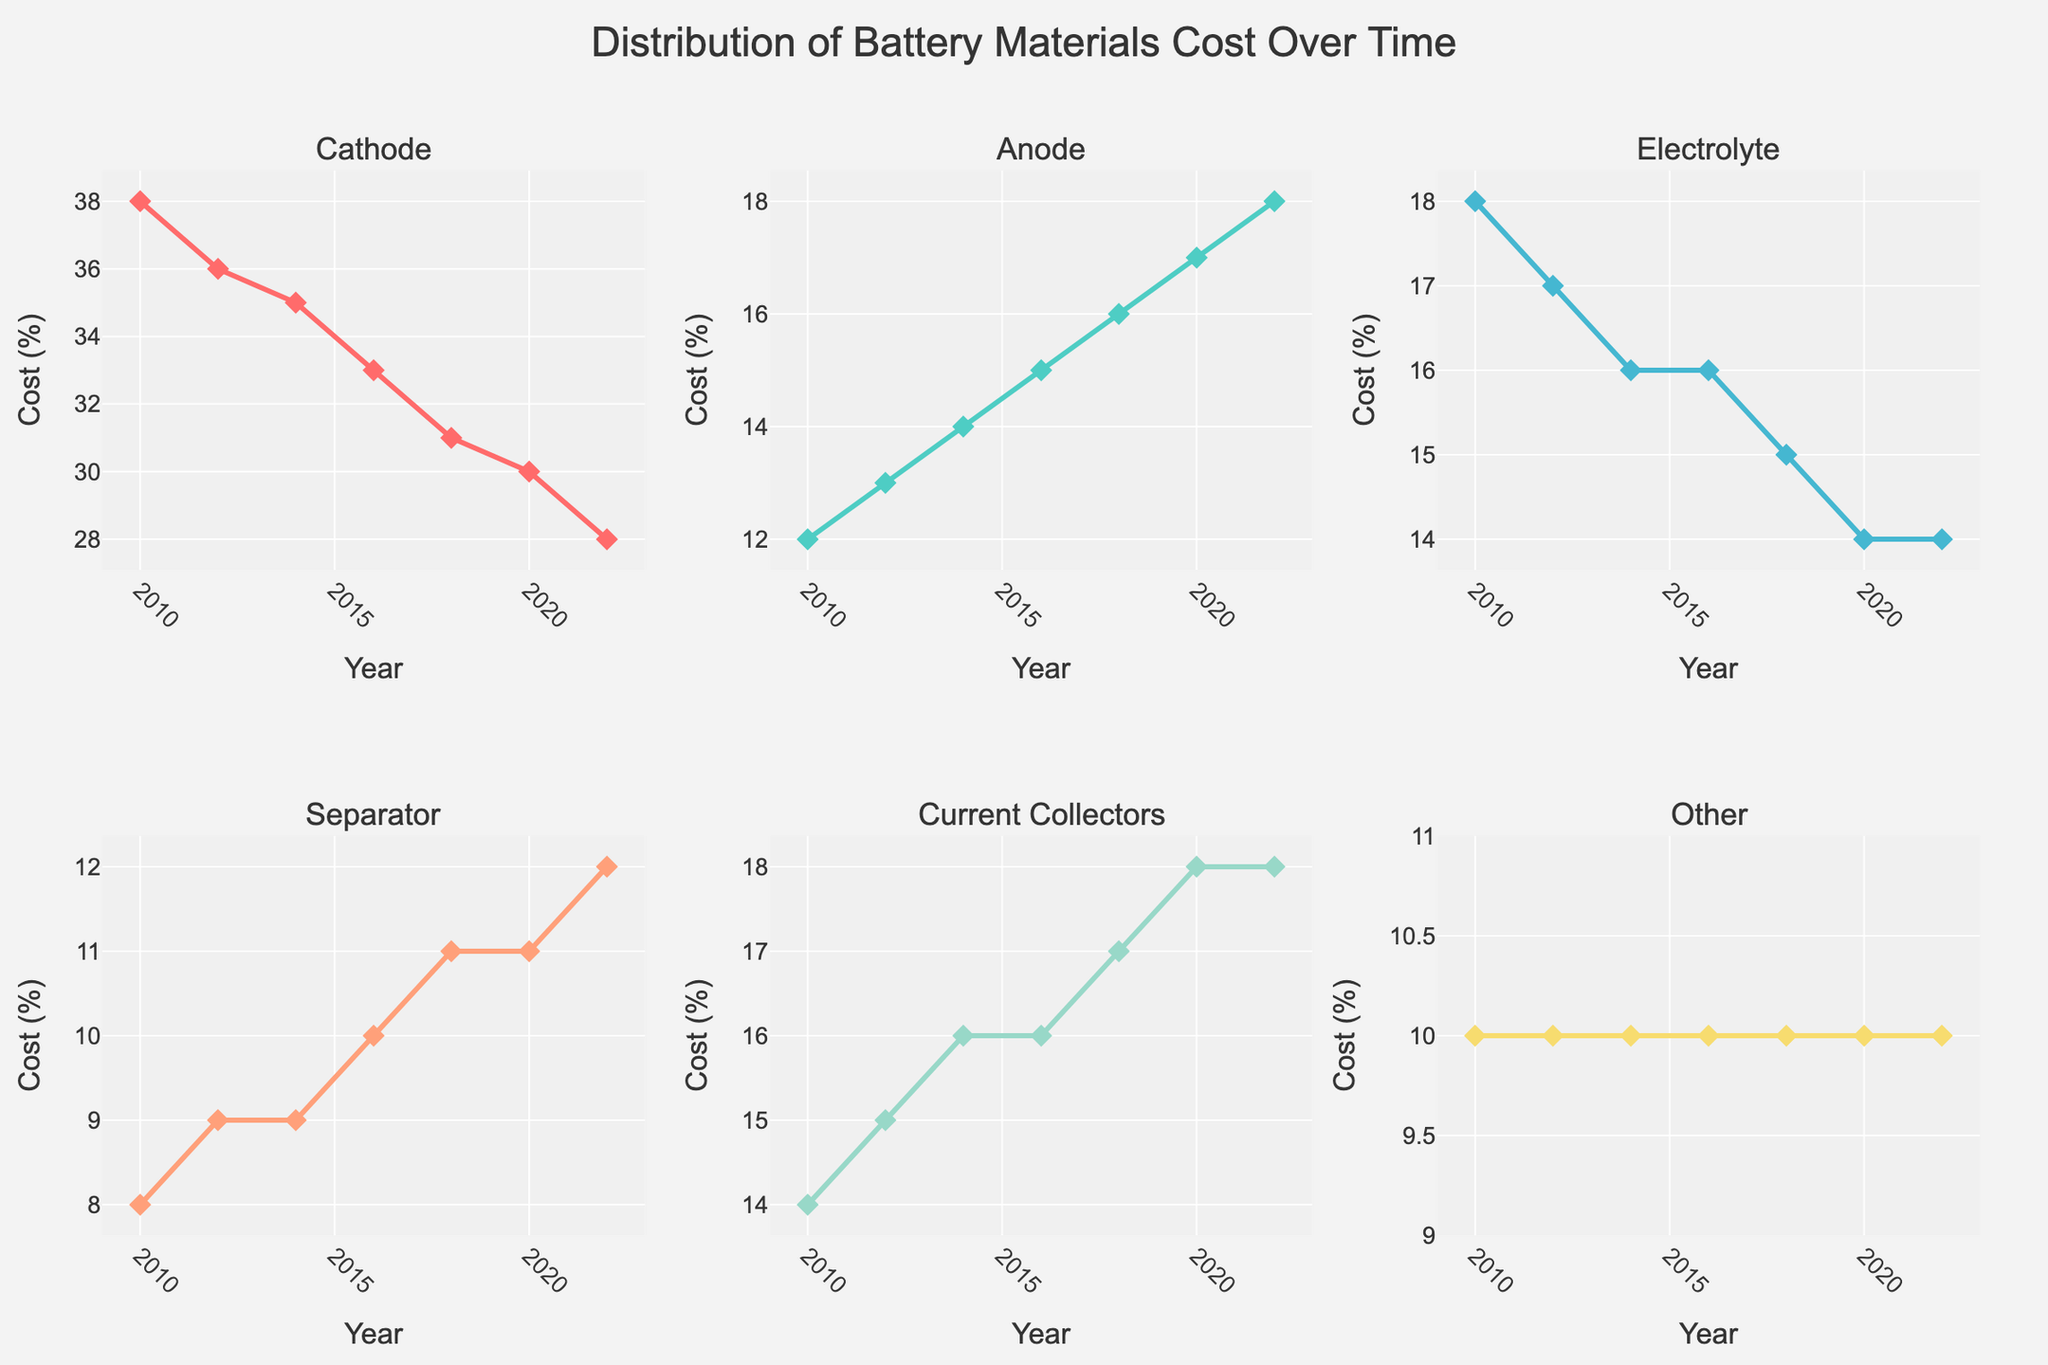What is the title of the figure? The title is usually displayed at the top of the figure. In this case, the title is "Distribution of Battery Materials Cost Over Time."
Answer: Distribution of Battery Materials Cost Over Time Which component had the highest cost percentage in 2022? Look at the subplot for each component and find the one with the highest value in 2022. The Cathode cost percentage is 28% while others are lower.
Answer: Cathode What is the trend for the cost percentage of the Electrolyte from 2010 to 2022? To determine the trend, observe the line in the Electrolyte subplot. The percentage drops from 18% to 14% from 2010 to 2016 and remains constant till 2022.
Answer: Decreasing then Stable By how much did the cost percentage of the Anode increase from 2010 to 2022? Subtract the Anode cost percentage in 2010 from that in 2022. The values are 12% in 2010 and 18% in 2022, a difference of 6%.
Answer: 6% Which component had the most fluctuation in cost percentage over the years? Compare the variability in trends across all subplots. Cathode has a noticeable declining trend, while Separator and Current Collectors show more consistent upward trends. Focus on those with wider fluctuations.
Answer: Cathode What is the average cost percentage of the Separator from 2010 to 2022? Add the Separator cost percentages from each year: 8 + 9 + 9 + 10 + 11 + 11 + 12 = 70. Divide by the number of years (7).
Answer: 10 What year did the Current Collectors cost percentage surpass the separator's cost percentage for the first time? Compare the values for Current Collectors and Separators across the years to see where Current Collectors first exceeds Separator's percentage. In 2016, both are equal at 10%, but in 2018, Current Collectors are 17% and Separator is 11%.
Answer: 2018 Rank the components by their cost percentage in 2010 from highest to lowest. Look at the data for 2010 for the categorization: Cathode (38%), Electrolyte (18%), Current Collectors (14%), Anode (12%), Separator (8%), Other (10%).
Answer: Cathode, Electrolyte, Current Collectors, Anode, Other, Separator Which component shows the smallest change in cost percentage from 2010 to 2022? Find the difference for each component over the period: Other remains 10%, making it the smallest change.
Answer: Other 